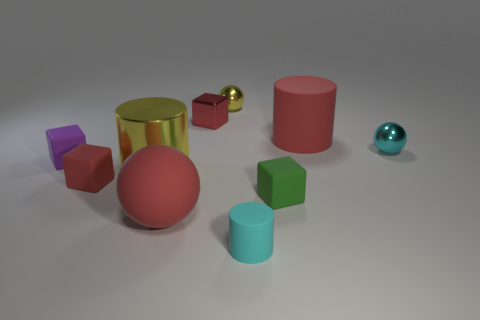Subtract 1 cubes. How many cubes are left? 3 Subtract all cubes. How many objects are left? 6 Subtract 0 brown cylinders. How many objects are left? 10 Subtract all purple matte cubes. Subtract all cyan rubber objects. How many objects are left? 8 Add 2 small metallic blocks. How many small metallic blocks are left? 3 Add 2 tiny purple metallic balls. How many tiny purple metallic balls exist? 2 